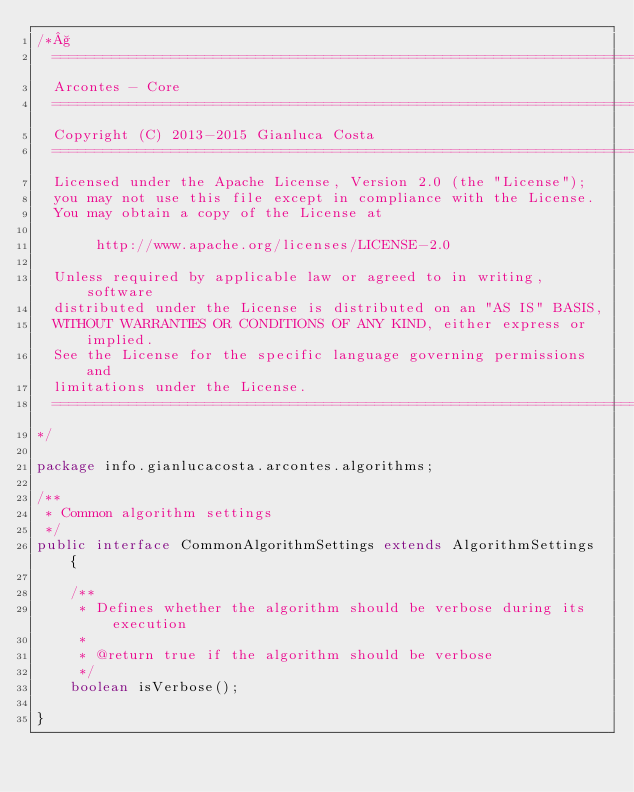Convert code to text. <code><loc_0><loc_0><loc_500><loc_500><_Java_>/*§
  ===========================================================================
  Arcontes - Core
  ===========================================================================
  Copyright (C) 2013-2015 Gianluca Costa
  ===========================================================================
  Licensed under the Apache License, Version 2.0 (the "License");
  you may not use this file except in compliance with the License.
  You may obtain a copy of the License at

       http://www.apache.org/licenses/LICENSE-2.0

  Unless required by applicable law or agreed to in writing, software
  distributed under the License is distributed on an "AS IS" BASIS,
  WITHOUT WARRANTIES OR CONDITIONS OF ANY KIND, either express or implied.
  See the License for the specific language governing permissions and
  limitations under the License.
  ===========================================================================
*/

package info.gianlucacosta.arcontes.algorithms;

/**
 * Common algorithm settings
 */
public interface CommonAlgorithmSettings extends AlgorithmSettings {

    /**
     * Defines whether the algorithm should be verbose during its execution
     *
     * @return true if the algorithm should be verbose
     */
    boolean isVerbose();

}
</code> 